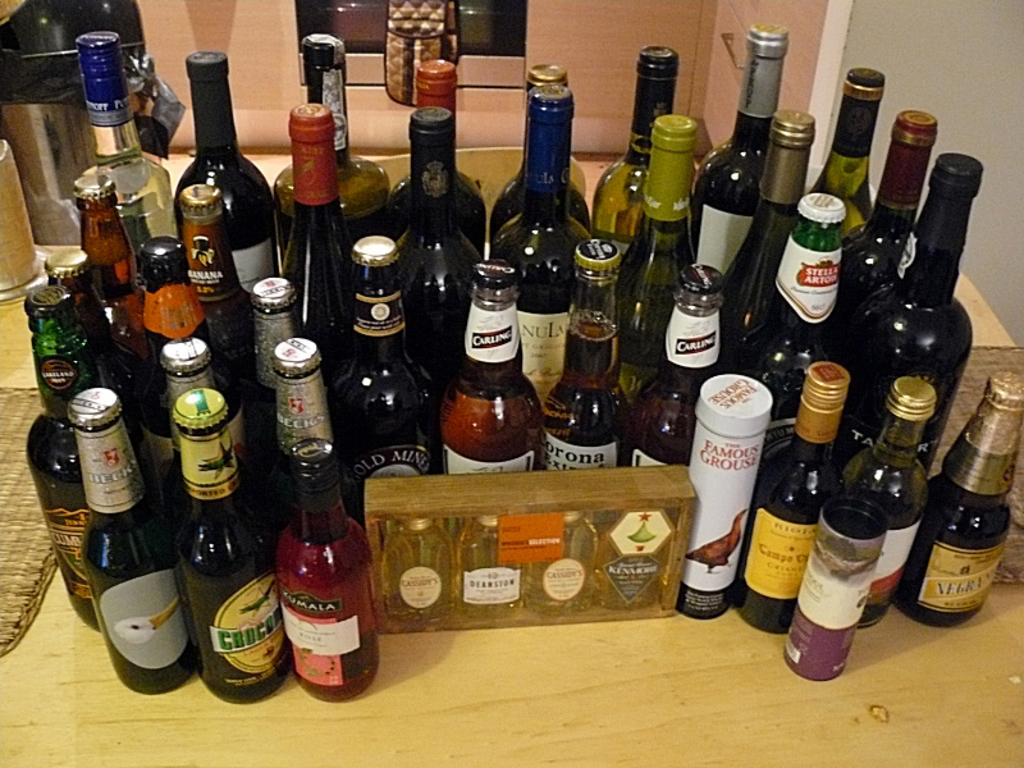<image>
Give a short and clear explanation of the subsequent image. Many bottles of beer and wine are  on the table and a corona is behind the box in the middle. 